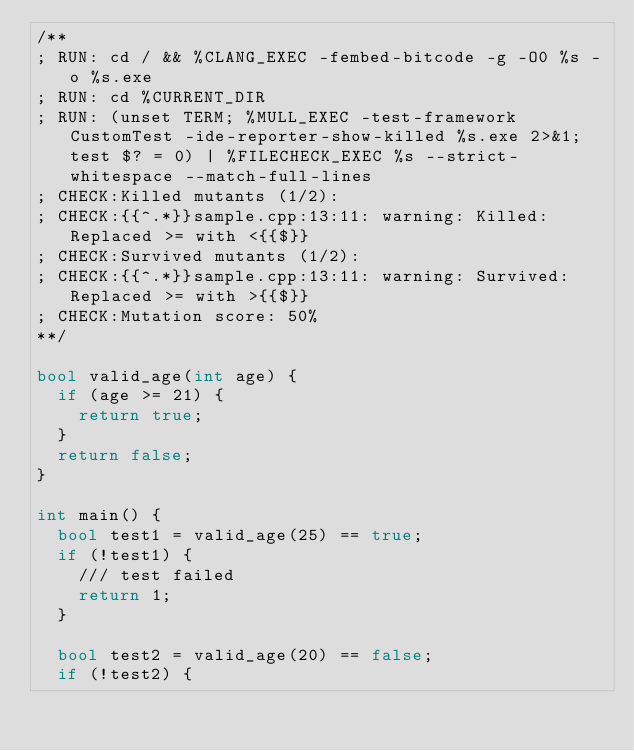Convert code to text. <code><loc_0><loc_0><loc_500><loc_500><_C++_>/**
; RUN: cd / && %CLANG_EXEC -fembed-bitcode -g -O0 %s -o %s.exe
; RUN: cd %CURRENT_DIR
; RUN: (unset TERM; %MULL_EXEC -test-framework CustomTest -ide-reporter-show-killed %s.exe 2>&1; test $? = 0) | %FILECHECK_EXEC %s --strict-whitespace --match-full-lines
; CHECK:Killed mutants (1/2):
; CHECK:{{^.*}}sample.cpp:13:11: warning: Killed: Replaced >= with <{{$}}
; CHECK:Survived mutants (1/2):
; CHECK:{{^.*}}sample.cpp:13:11: warning: Survived: Replaced >= with >{{$}}
; CHECK:Mutation score: 50%
**/

bool valid_age(int age) {
  if (age >= 21) {
    return true;
  }
  return false;
}

int main() {
  bool test1 = valid_age(25) == true;
  if (!test1) {
    /// test failed
    return 1;
  }

  bool test2 = valid_age(20) == false;
  if (!test2) {</code> 